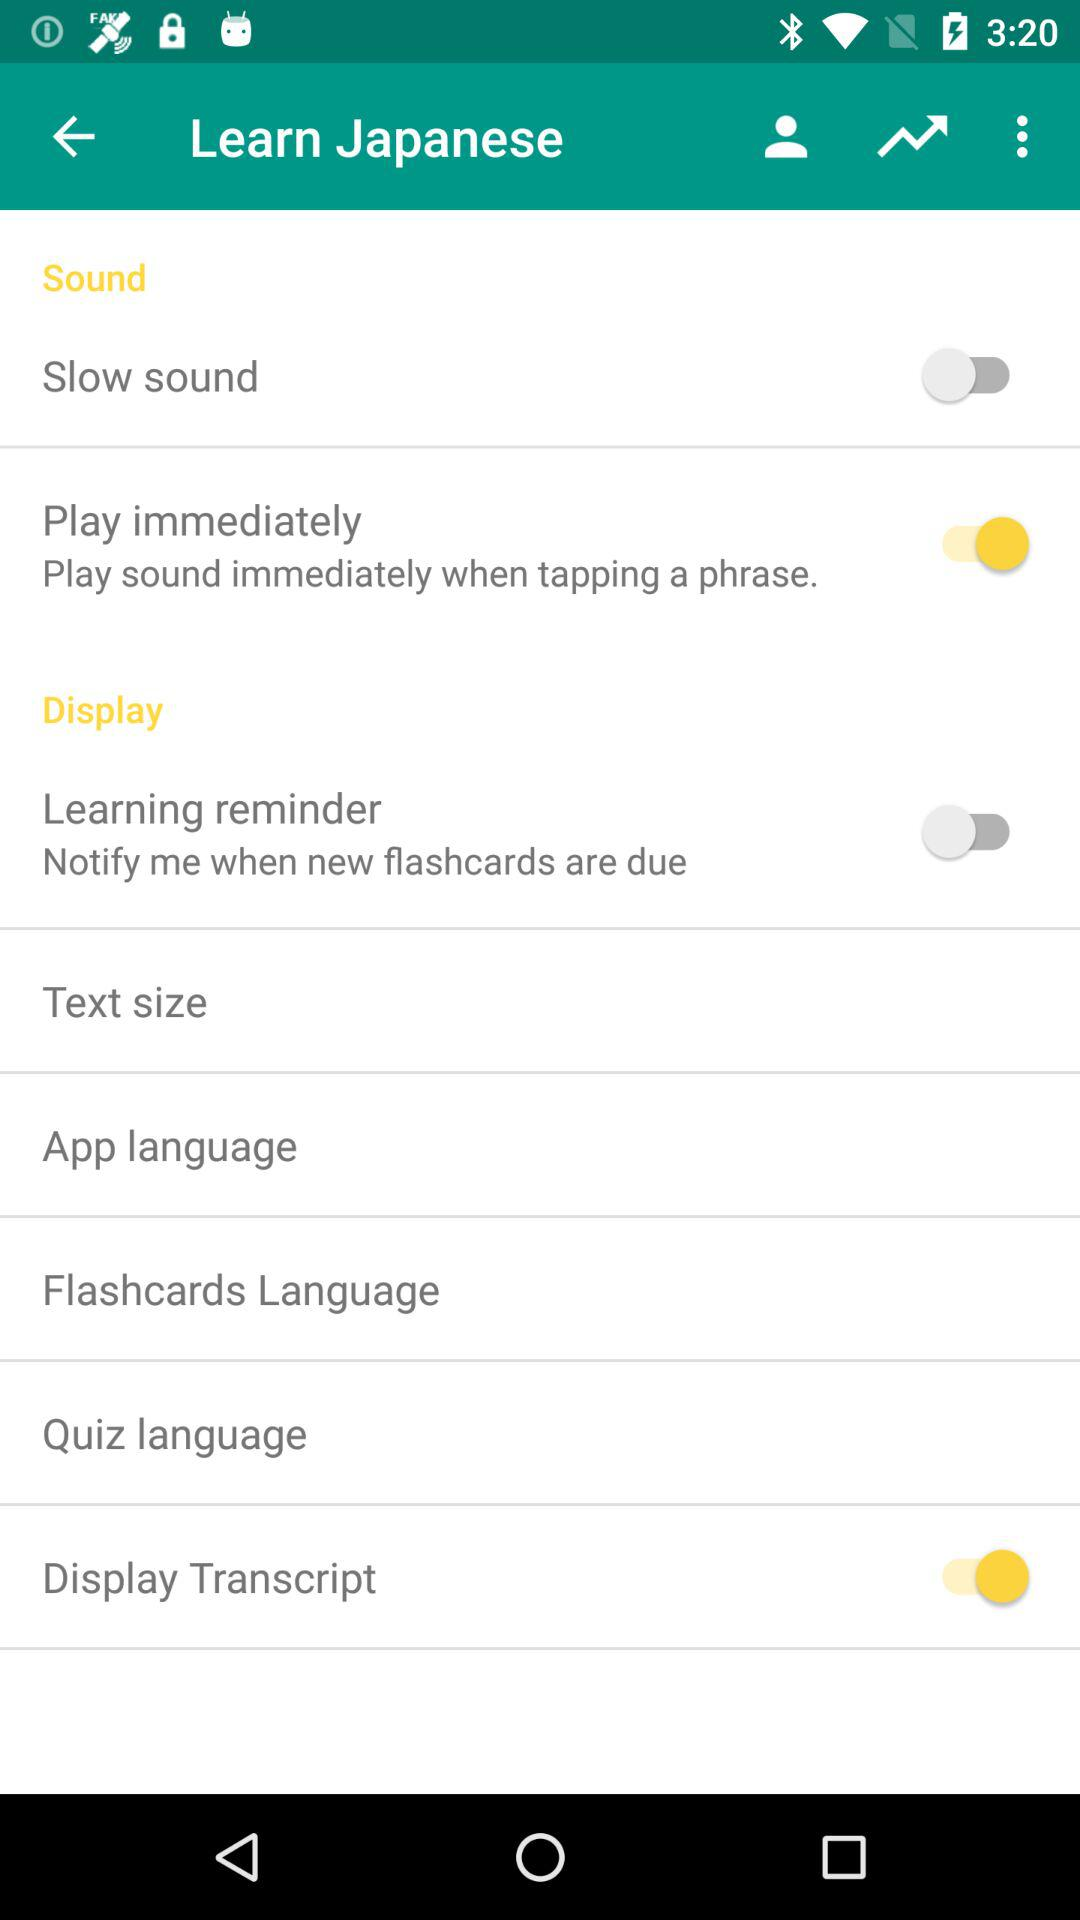Are there any settings currently enabled on this screen? Yes, the 'Play immediately' and 'Flashcards Language' settings are currently enabled, as indicated by their yellow toggles shifted to the right. 